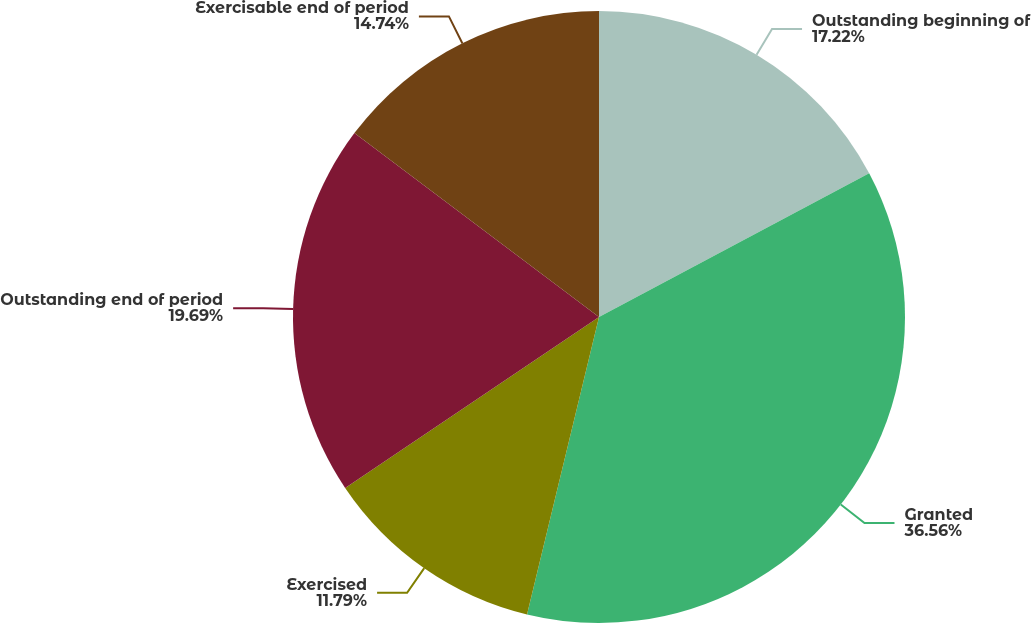Convert chart. <chart><loc_0><loc_0><loc_500><loc_500><pie_chart><fcel>Outstanding beginning of<fcel>Granted<fcel>Exercised<fcel>Outstanding end of period<fcel>Exercisable end of period<nl><fcel>17.22%<fcel>36.56%<fcel>11.79%<fcel>19.69%<fcel>14.74%<nl></chart> 